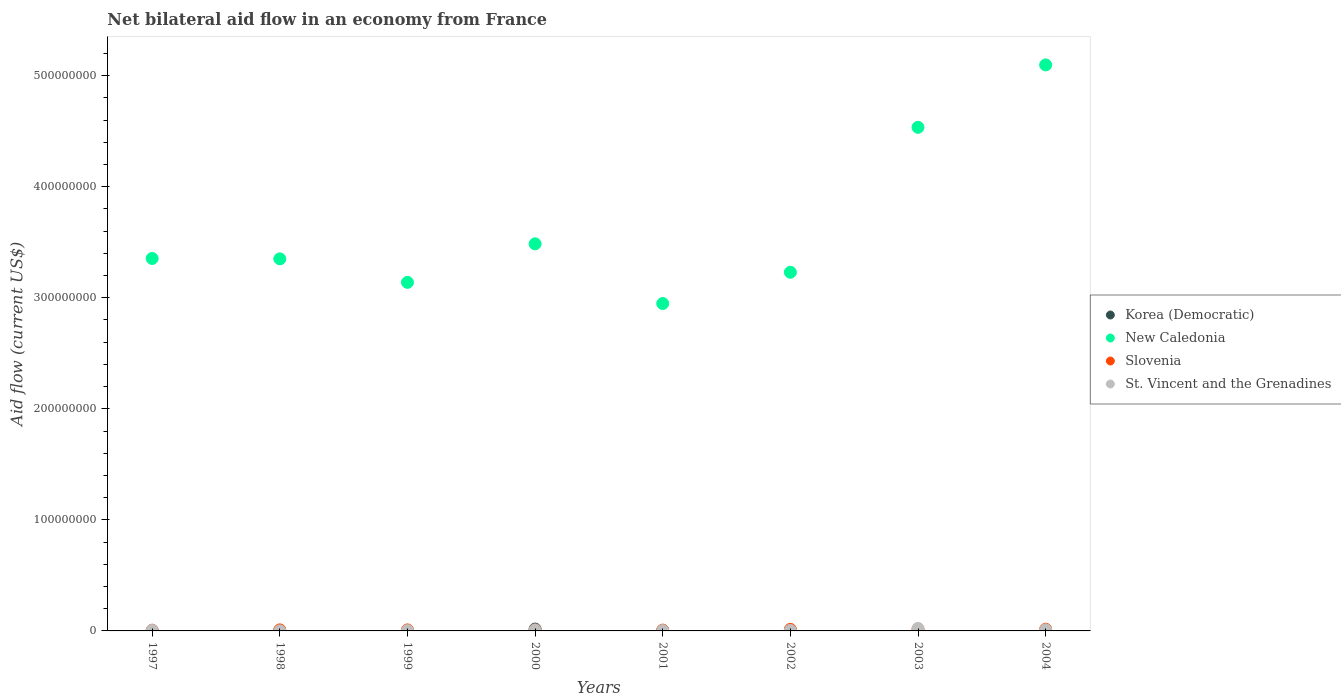What is the net bilateral aid flow in St. Vincent and the Grenadines in 2003?
Give a very brief answer. 2.23e+06. Across all years, what is the maximum net bilateral aid flow in Korea (Democratic)?
Your answer should be compact. 1.69e+06. In which year was the net bilateral aid flow in Korea (Democratic) maximum?
Keep it short and to the point. 2000. What is the total net bilateral aid flow in Slovenia in the graph?
Offer a terse response. 8.46e+06. What is the difference between the net bilateral aid flow in New Caledonia in 1999 and that in 2000?
Keep it short and to the point. -3.47e+07. What is the average net bilateral aid flow in New Caledonia per year?
Offer a very short reply. 3.64e+08. In the year 1998, what is the difference between the net bilateral aid flow in Korea (Democratic) and net bilateral aid flow in Slovenia?
Offer a very short reply. -8.50e+05. In how many years, is the net bilateral aid flow in Slovenia greater than 220000000 US$?
Give a very brief answer. 0. What is the ratio of the net bilateral aid flow in St. Vincent and the Grenadines in 2002 to that in 2004?
Your response must be concise. 0.48. Is the net bilateral aid flow in Slovenia in 2001 less than that in 2002?
Keep it short and to the point. Yes. What is the difference between the highest and the second highest net bilateral aid flow in St. Vincent and the Grenadines?
Your response must be concise. 1.20e+06. What is the difference between the highest and the lowest net bilateral aid flow in St. Vincent and the Grenadines?
Provide a short and direct response. 2.15e+06. Is the sum of the net bilateral aid flow in Slovenia in 1998 and 2003 greater than the maximum net bilateral aid flow in St. Vincent and the Grenadines across all years?
Offer a very short reply. Yes. Is it the case that in every year, the sum of the net bilateral aid flow in Slovenia and net bilateral aid flow in New Caledonia  is greater than the sum of net bilateral aid flow in Korea (Democratic) and net bilateral aid flow in St. Vincent and the Grenadines?
Offer a very short reply. Yes. Is the net bilateral aid flow in St. Vincent and the Grenadines strictly greater than the net bilateral aid flow in Korea (Democratic) over the years?
Provide a succinct answer. No. Is the net bilateral aid flow in New Caledonia strictly less than the net bilateral aid flow in Korea (Democratic) over the years?
Provide a succinct answer. No. How many years are there in the graph?
Provide a succinct answer. 8. What is the difference between two consecutive major ticks on the Y-axis?
Provide a short and direct response. 1.00e+08. Does the graph contain any zero values?
Provide a succinct answer. Yes. Where does the legend appear in the graph?
Make the answer very short. Center right. How many legend labels are there?
Provide a short and direct response. 4. How are the legend labels stacked?
Offer a terse response. Vertical. What is the title of the graph?
Offer a very short reply. Net bilateral aid flow in an economy from France. Does "Liberia" appear as one of the legend labels in the graph?
Give a very brief answer. No. What is the Aid flow (current US$) of Korea (Democratic) in 1997?
Give a very brief answer. 10000. What is the Aid flow (current US$) in New Caledonia in 1997?
Offer a very short reply. 3.35e+08. What is the Aid flow (current US$) of Slovenia in 1997?
Offer a very short reply. 6.60e+05. What is the Aid flow (current US$) of St. Vincent and the Grenadines in 1997?
Your response must be concise. 5.20e+05. What is the Aid flow (current US$) of Korea (Democratic) in 1998?
Your answer should be compact. 8.00e+04. What is the Aid flow (current US$) of New Caledonia in 1998?
Your response must be concise. 3.35e+08. What is the Aid flow (current US$) in Slovenia in 1998?
Give a very brief answer. 9.30e+05. What is the Aid flow (current US$) in New Caledonia in 1999?
Offer a terse response. 3.14e+08. What is the Aid flow (current US$) of Slovenia in 1999?
Keep it short and to the point. 9.00e+05. What is the Aid flow (current US$) in St. Vincent and the Grenadines in 1999?
Keep it short and to the point. 3.60e+05. What is the Aid flow (current US$) of Korea (Democratic) in 2000?
Your response must be concise. 1.69e+06. What is the Aid flow (current US$) of New Caledonia in 2000?
Give a very brief answer. 3.49e+08. What is the Aid flow (current US$) in Slovenia in 2000?
Make the answer very short. 8.50e+05. What is the Aid flow (current US$) in St. Vincent and the Grenadines in 2000?
Your answer should be compact. 8.70e+05. What is the Aid flow (current US$) in Korea (Democratic) in 2001?
Provide a short and direct response. 2.70e+05. What is the Aid flow (current US$) of New Caledonia in 2001?
Your answer should be compact. 2.95e+08. What is the Aid flow (current US$) in Slovenia in 2001?
Offer a terse response. 7.40e+05. What is the Aid flow (current US$) in New Caledonia in 2002?
Give a very brief answer. 3.23e+08. What is the Aid flow (current US$) of Slovenia in 2002?
Offer a terse response. 1.40e+06. What is the Aid flow (current US$) of St. Vincent and the Grenadines in 2002?
Keep it short and to the point. 4.90e+05. What is the Aid flow (current US$) in New Caledonia in 2003?
Keep it short and to the point. 4.53e+08. What is the Aid flow (current US$) in Slovenia in 2003?
Give a very brief answer. 1.44e+06. What is the Aid flow (current US$) in St. Vincent and the Grenadines in 2003?
Your response must be concise. 2.23e+06. What is the Aid flow (current US$) of New Caledonia in 2004?
Offer a terse response. 5.10e+08. What is the Aid flow (current US$) in Slovenia in 2004?
Make the answer very short. 1.54e+06. What is the Aid flow (current US$) in St. Vincent and the Grenadines in 2004?
Make the answer very short. 1.03e+06. Across all years, what is the maximum Aid flow (current US$) in Korea (Democratic)?
Provide a short and direct response. 1.69e+06. Across all years, what is the maximum Aid flow (current US$) in New Caledonia?
Your response must be concise. 5.10e+08. Across all years, what is the maximum Aid flow (current US$) in Slovenia?
Keep it short and to the point. 1.54e+06. Across all years, what is the maximum Aid flow (current US$) of St. Vincent and the Grenadines?
Your answer should be very brief. 2.23e+06. Across all years, what is the minimum Aid flow (current US$) in New Caledonia?
Ensure brevity in your answer.  2.95e+08. What is the total Aid flow (current US$) of Korea (Democratic) in the graph?
Your answer should be compact. 2.59e+06. What is the total Aid flow (current US$) in New Caledonia in the graph?
Provide a succinct answer. 2.91e+09. What is the total Aid flow (current US$) of Slovenia in the graph?
Give a very brief answer. 8.46e+06. What is the total Aid flow (current US$) of St. Vincent and the Grenadines in the graph?
Keep it short and to the point. 5.88e+06. What is the difference between the Aid flow (current US$) of Korea (Democratic) in 1997 and that in 1998?
Give a very brief answer. -7.00e+04. What is the difference between the Aid flow (current US$) of Korea (Democratic) in 1997 and that in 1999?
Your answer should be compact. -6.00e+04. What is the difference between the Aid flow (current US$) in New Caledonia in 1997 and that in 1999?
Keep it short and to the point. 2.15e+07. What is the difference between the Aid flow (current US$) of Korea (Democratic) in 1997 and that in 2000?
Ensure brevity in your answer.  -1.68e+06. What is the difference between the Aid flow (current US$) in New Caledonia in 1997 and that in 2000?
Provide a short and direct response. -1.32e+07. What is the difference between the Aid flow (current US$) of St. Vincent and the Grenadines in 1997 and that in 2000?
Keep it short and to the point. -3.50e+05. What is the difference between the Aid flow (current US$) in New Caledonia in 1997 and that in 2001?
Give a very brief answer. 4.06e+07. What is the difference between the Aid flow (current US$) in Korea (Democratic) in 1997 and that in 2002?
Offer a terse response. -4.60e+05. What is the difference between the Aid flow (current US$) of New Caledonia in 1997 and that in 2002?
Your response must be concise. 1.24e+07. What is the difference between the Aid flow (current US$) of Slovenia in 1997 and that in 2002?
Provide a short and direct response. -7.40e+05. What is the difference between the Aid flow (current US$) in New Caledonia in 1997 and that in 2003?
Ensure brevity in your answer.  -1.18e+08. What is the difference between the Aid flow (current US$) in Slovenia in 1997 and that in 2003?
Keep it short and to the point. -7.80e+05. What is the difference between the Aid flow (current US$) of St. Vincent and the Grenadines in 1997 and that in 2003?
Your response must be concise. -1.71e+06. What is the difference between the Aid flow (current US$) in New Caledonia in 1997 and that in 2004?
Keep it short and to the point. -1.74e+08. What is the difference between the Aid flow (current US$) of Slovenia in 1997 and that in 2004?
Provide a succinct answer. -8.80e+05. What is the difference between the Aid flow (current US$) in St. Vincent and the Grenadines in 1997 and that in 2004?
Make the answer very short. -5.10e+05. What is the difference between the Aid flow (current US$) of Korea (Democratic) in 1998 and that in 1999?
Offer a very short reply. 10000. What is the difference between the Aid flow (current US$) of New Caledonia in 1998 and that in 1999?
Offer a terse response. 2.12e+07. What is the difference between the Aid flow (current US$) of Slovenia in 1998 and that in 1999?
Provide a short and direct response. 3.00e+04. What is the difference between the Aid flow (current US$) in St. Vincent and the Grenadines in 1998 and that in 1999?
Your answer should be compact. -2.80e+05. What is the difference between the Aid flow (current US$) of Korea (Democratic) in 1998 and that in 2000?
Give a very brief answer. -1.61e+06. What is the difference between the Aid flow (current US$) of New Caledonia in 1998 and that in 2000?
Offer a very short reply. -1.35e+07. What is the difference between the Aid flow (current US$) of St. Vincent and the Grenadines in 1998 and that in 2000?
Your answer should be compact. -7.90e+05. What is the difference between the Aid flow (current US$) in New Caledonia in 1998 and that in 2001?
Your answer should be very brief. 4.02e+07. What is the difference between the Aid flow (current US$) in Slovenia in 1998 and that in 2001?
Provide a succinct answer. 1.90e+05. What is the difference between the Aid flow (current US$) of Korea (Democratic) in 1998 and that in 2002?
Make the answer very short. -3.90e+05. What is the difference between the Aid flow (current US$) in New Caledonia in 1998 and that in 2002?
Ensure brevity in your answer.  1.21e+07. What is the difference between the Aid flow (current US$) of Slovenia in 1998 and that in 2002?
Keep it short and to the point. -4.70e+05. What is the difference between the Aid flow (current US$) of St. Vincent and the Grenadines in 1998 and that in 2002?
Offer a terse response. -4.10e+05. What is the difference between the Aid flow (current US$) in New Caledonia in 1998 and that in 2003?
Offer a very short reply. -1.18e+08. What is the difference between the Aid flow (current US$) of Slovenia in 1998 and that in 2003?
Give a very brief answer. -5.10e+05. What is the difference between the Aid flow (current US$) in St. Vincent and the Grenadines in 1998 and that in 2003?
Provide a succinct answer. -2.15e+06. What is the difference between the Aid flow (current US$) in New Caledonia in 1998 and that in 2004?
Make the answer very short. -1.75e+08. What is the difference between the Aid flow (current US$) in Slovenia in 1998 and that in 2004?
Offer a terse response. -6.10e+05. What is the difference between the Aid flow (current US$) in St. Vincent and the Grenadines in 1998 and that in 2004?
Offer a terse response. -9.50e+05. What is the difference between the Aid flow (current US$) of Korea (Democratic) in 1999 and that in 2000?
Provide a succinct answer. -1.62e+06. What is the difference between the Aid flow (current US$) of New Caledonia in 1999 and that in 2000?
Keep it short and to the point. -3.47e+07. What is the difference between the Aid flow (current US$) in Slovenia in 1999 and that in 2000?
Make the answer very short. 5.00e+04. What is the difference between the Aid flow (current US$) in St. Vincent and the Grenadines in 1999 and that in 2000?
Give a very brief answer. -5.10e+05. What is the difference between the Aid flow (current US$) in Korea (Democratic) in 1999 and that in 2001?
Give a very brief answer. -2.00e+05. What is the difference between the Aid flow (current US$) of New Caledonia in 1999 and that in 2001?
Provide a short and direct response. 1.91e+07. What is the difference between the Aid flow (current US$) in Korea (Democratic) in 1999 and that in 2002?
Your answer should be very brief. -4.00e+05. What is the difference between the Aid flow (current US$) of New Caledonia in 1999 and that in 2002?
Offer a terse response. -9.07e+06. What is the difference between the Aid flow (current US$) in Slovenia in 1999 and that in 2002?
Give a very brief answer. -5.00e+05. What is the difference between the Aid flow (current US$) of St. Vincent and the Grenadines in 1999 and that in 2002?
Your response must be concise. -1.30e+05. What is the difference between the Aid flow (current US$) in New Caledonia in 1999 and that in 2003?
Your answer should be compact. -1.40e+08. What is the difference between the Aid flow (current US$) of Slovenia in 1999 and that in 2003?
Make the answer very short. -5.40e+05. What is the difference between the Aid flow (current US$) of St. Vincent and the Grenadines in 1999 and that in 2003?
Provide a succinct answer. -1.87e+06. What is the difference between the Aid flow (current US$) in New Caledonia in 1999 and that in 2004?
Ensure brevity in your answer.  -1.96e+08. What is the difference between the Aid flow (current US$) of Slovenia in 1999 and that in 2004?
Provide a short and direct response. -6.40e+05. What is the difference between the Aid flow (current US$) of St. Vincent and the Grenadines in 1999 and that in 2004?
Offer a terse response. -6.70e+05. What is the difference between the Aid flow (current US$) of Korea (Democratic) in 2000 and that in 2001?
Provide a succinct answer. 1.42e+06. What is the difference between the Aid flow (current US$) in New Caledonia in 2000 and that in 2001?
Provide a succinct answer. 5.37e+07. What is the difference between the Aid flow (current US$) of St. Vincent and the Grenadines in 2000 and that in 2001?
Offer a terse response. 5.70e+05. What is the difference between the Aid flow (current US$) in Korea (Democratic) in 2000 and that in 2002?
Provide a short and direct response. 1.22e+06. What is the difference between the Aid flow (current US$) in New Caledonia in 2000 and that in 2002?
Keep it short and to the point. 2.56e+07. What is the difference between the Aid flow (current US$) of Slovenia in 2000 and that in 2002?
Keep it short and to the point. -5.50e+05. What is the difference between the Aid flow (current US$) of St. Vincent and the Grenadines in 2000 and that in 2002?
Offer a terse response. 3.80e+05. What is the difference between the Aid flow (current US$) of New Caledonia in 2000 and that in 2003?
Make the answer very short. -1.05e+08. What is the difference between the Aid flow (current US$) of Slovenia in 2000 and that in 2003?
Your answer should be very brief. -5.90e+05. What is the difference between the Aid flow (current US$) of St. Vincent and the Grenadines in 2000 and that in 2003?
Ensure brevity in your answer.  -1.36e+06. What is the difference between the Aid flow (current US$) in New Caledonia in 2000 and that in 2004?
Your response must be concise. -1.61e+08. What is the difference between the Aid flow (current US$) of Slovenia in 2000 and that in 2004?
Your response must be concise. -6.90e+05. What is the difference between the Aid flow (current US$) in St. Vincent and the Grenadines in 2000 and that in 2004?
Ensure brevity in your answer.  -1.60e+05. What is the difference between the Aid flow (current US$) of Korea (Democratic) in 2001 and that in 2002?
Provide a succinct answer. -2.00e+05. What is the difference between the Aid flow (current US$) of New Caledonia in 2001 and that in 2002?
Keep it short and to the point. -2.81e+07. What is the difference between the Aid flow (current US$) in Slovenia in 2001 and that in 2002?
Offer a very short reply. -6.60e+05. What is the difference between the Aid flow (current US$) in New Caledonia in 2001 and that in 2003?
Provide a short and direct response. -1.59e+08. What is the difference between the Aid flow (current US$) in Slovenia in 2001 and that in 2003?
Your response must be concise. -7.00e+05. What is the difference between the Aid flow (current US$) of St. Vincent and the Grenadines in 2001 and that in 2003?
Make the answer very short. -1.93e+06. What is the difference between the Aid flow (current US$) in New Caledonia in 2001 and that in 2004?
Your response must be concise. -2.15e+08. What is the difference between the Aid flow (current US$) in Slovenia in 2001 and that in 2004?
Your response must be concise. -8.00e+05. What is the difference between the Aid flow (current US$) in St. Vincent and the Grenadines in 2001 and that in 2004?
Give a very brief answer. -7.30e+05. What is the difference between the Aid flow (current US$) of New Caledonia in 2002 and that in 2003?
Ensure brevity in your answer.  -1.31e+08. What is the difference between the Aid flow (current US$) in Slovenia in 2002 and that in 2003?
Your answer should be very brief. -4.00e+04. What is the difference between the Aid flow (current US$) of St. Vincent and the Grenadines in 2002 and that in 2003?
Offer a very short reply. -1.74e+06. What is the difference between the Aid flow (current US$) in New Caledonia in 2002 and that in 2004?
Your response must be concise. -1.87e+08. What is the difference between the Aid flow (current US$) in Slovenia in 2002 and that in 2004?
Ensure brevity in your answer.  -1.40e+05. What is the difference between the Aid flow (current US$) of St. Vincent and the Grenadines in 2002 and that in 2004?
Your response must be concise. -5.40e+05. What is the difference between the Aid flow (current US$) of New Caledonia in 2003 and that in 2004?
Make the answer very short. -5.62e+07. What is the difference between the Aid flow (current US$) of Slovenia in 2003 and that in 2004?
Provide a succinct answer. -1.00e+05. What is the difference between the Aid flow (current US$) in St. Vincent and the Grenadines in 2003 and that in 2004?
Your answer should be very brief. 1.20e+06. What is the difference between the Aid flow (current US$) in Korea (Democratic) in 1997 and the Aid flow (current US$) in New Caledonia in 1998?
Your answer should be compact. -3.35e+08. What is the difference between the Aid flow (current US$) of Korea (Democratic) in 1997 and the Aid flow (current US$) of Slovenia in 1998?
Provide a short and direct response. -9.20e+05. What is the difference between the Aid flow (current US$) in Korea (Democratic) in 1997 and the Aid flow (current US$) in St. Vincent and the Grenadines in 1998?
Offer a very short reply. -7.00e+04. What is the difference between the Aid flow (current US$) of New Caledonia in 1997 and the Aid flow (current US$) of Slovenia in 1998?
Keep it short and to the point. 3.34e+08. What is the difference between the Aid flow (current US$) in New Caledonia in 1997 and the Aid flow (current US$) in St. Vincent and the Grenadines in 1998?
Your answer should be compact. 3.35e+08. What is the difference between the Aid flow (current US$) of Slovenia in 1997 and the Aid flow (current US$) of St. Vincent and the Grenadines in 1998?
Provide a short and direct response. 5.80e+05. What is the difference between the Aid flow (current US$) in Korea (Democratic) in 1997 and the Aid flow (current US$) in New Caledonia in 1999?
Make the answer very short. -3.14e+08. What is the difference between the Aid flow (current US$) of Korea (Democratic) in 1997 and the Aid flow (current US$) of Slovenia in 1999?
Keep it short and to the point. -8.90e+05. What is the difference between the Aid flow (current US$) of Korea (Democratic) in 1997 and the Aid flow (current US$) of St. Vincent and the Grenadines in 1999?
Provide a succinct answer. -3.50e+05. What is the difference between the Aid flow (current US$) of New Caledonia in 1997 and the Aid flow (current US$) of Slovenia in 1999?
Provide a succinct answer. 3.34e+08. What is the difference between the Aid flow (current US$) in New Caledonia in 1997 and the Aid flow (current US$) in St. Vincent and the Grenadines in 1999?
Your answer should be very brief. 3.35e+08. What is the difference between the Aid flow (current US$) in Slovenia in 1997 and the Aid flow (current US$) in St. Vincent and the Grenadines in 1999?
Your answer should be very brief. 3.00e+05. What is the difference between the Aid flow (current US$) of Korea (Democratic) in 1997 and the Aid flow (current US$) of New Caledonia in 2000?
Your answer should be very brief. -3.49e+08. What is the difference between the Aid flow (current US$) in Korea (Democratic) in 1997 and the Aid flow (current US$) in Slovenia in 2000?
Ensure brevity in your answer.  -8.40e+05. What is the difference between the Aid flow (current US$) in Korea (Democratic) in 1997 and the Aid flow (current US$) in St. Vincent and the Grenadines in 2000?
Keep it short and to the point. -8.60e+05. What is the difference between the Aid flow (current US$) of New Caledonia in 1997 and the Aid flow (current US$) of Slovenia in 2000?
Provide a succinct answer. 3.35e+08. What is the difference between the Aid flow (current US$) in New Caledonia in 1997 and the Aid flow (current US$) in St. Vincent and the Grenadines in 2000?
Give a very brief answer. 3.35e+08. What is the difference between the Aid flow (current US$) of Slovenia in 1997 and the Aid flow (current US$) of St. Vincent and the Grenadines in 2000?
Your answer should be very brief. -2.10e+05. What is the difference between the Aid flow (current US$) in Korea (Democratic) in 1997 and the Aid flow (current US$) in New Caledonia in 2001?
Make the answer very short. -2.95e+08. What is the difference between the Aid flow (current US$) in Korea (Democratic) in 1997 and the Aid flow (current US$) in Slovenia in 2001?
Keep it short and to the point. -7.30e+05. What is the difference between the Aid flow (current US$) in Korea (Democratic) in 1997 and the Aid flow (current US$) in St. Vincent and the Grenadines in 2001?
Offer a very short reply. -2.90e+05. What is the difference between the Aid flow (current US$) in New Caledonia in 1997 and the Aid flow (current US$) in Slovenia in 2001?
Provide a short and direct response. 3.35e+08. What is the difference between the Aid flow (current US$) of New Caledonia in 1997 and the Aid flow (current US$) of St. Vincent and the Grenadines in 2001?
Keep it short and to the point. 3.35e+08. What is the difference between the Aid flow (current US$) of Korea (Democratic) in 1997 and the Aid flow (current US$) of New Caledonia in 2002?
Offer a terse response. -3.23e+08. What is the difference between the Aid flow (current US$) of Korea (Democratic) in 1997 and the Aid flow (current US$) of Slovenia in 2002?
Offer a terse response. -1.39e+06. What is the difference between the Aid flow (current US$) of Korea (Democratic) in 1997 and the Aid flow (current US$) of St. Vincent and the Grenadines in 2002?
Ensure brevity in your answer.  -4.80e+05. What is the difference between the Aid flow (current US$) in New Caledonia in 1997 and the Aid flow (current US$) in Slovenia in 2002?
Keep it short and to the point. 3.34e+08. What is the difference between the Aid flow (current US$) in New Caledonia in 1997 and the Aid flow (current US$) in St. Vincent and the Grenadines in 2002?
Keep it short and to the point. 3.35e+08. What is the difference between the Aid flow (current US$) in Slovenia in 1997 and the Aid flow (current US$) in St. Vincent and the Grenadines in 2002?
Your response must be concise. 1.70e+05. What is the difference between the Aid flow (current US$) in Korea (Democratic) in 1997 and the Aid flow (current US$) in New Caledonia in 2003?
Your response must be concise. -4.53e+08. What is the difference between the Aid flow (current US$) in Korea (Democratic) in 1997 and the Aid flow (current US$) in Slovenia in 2003?
Provide a succinct answer. -1.43e+06. What is the difference between the Aid flow (current US$) of Korea (Democratic) in 1997 and the Aid flow (current US$) of St. Vincent and the Grenadines in 2003?
Your response must be concise. -2.22e+06. What is the difference between the Aid flow (current US$) of New Caledonia in 1997 and the Aid flow (current US$) of Slovenia in 2003?
Your answer should be compact. 3.34e+08. What is the difference between the Aid flow (current US$) in New Caledonia in 1997 and the Aid flow (current US$) in St. Vincent and the Grenadines in 2003?
Your answer should be very brief. 3.33e+08. What is the difference between the Aid flow (current US$) of Slovenia in 1997 and the Aid flow (current US$) of St. Vincent and the Grenadines in 2003?
Provide a short and direct response. -1.57e+06. What is the difference between the Aid flow (current US$) in Korea (Democratic) in 1997 and the Aid flow (current US$) in New Caledonia in 2004?
Offer a very short reply. -5.10e+08. What is the difference between the Aid flow (current US$) of Korea (Democratic) in 1997 and the Aid flow (current US$) of Slovenia in 2004?
Offer a terse response. -1.53e+06. What is the difference between the Aid flow (current US$) in Korea (Democratic) in 1997 and the Aid flow (current US$) in St. Vincent and the Grenadines in 2004?
Ensure brevity in your answer.  -1.02e+06. What is the difference between the Aid flow (current US$) of New Caledonia in 1997 and the Aid flow (current US$) of Slovenia in 2004?
Provide a short and direct response. 3.34e+08. What is the difference between the Aid flow (current US$) of New Caledonia in 1997 and the Aid flow (current US$) of St. Vincent and the Grenadines in 2004?
Your answer should be very brief. 3.34e+08. What is the difference between the Aid flow (current US$) of Slovenia in 1997 and the Aid flow (current US$) of St. Vincent and the Grenadines in 2004?
Provide a succinct answer. -3.70e+05. What is the difference between the Aid flow (current US$) in Korea (Democratic) in 1998 and the Aid flow (current US$) in New Caledonia in 1999?
Offer a terse response. -3.14e+08. What is the difference between the Aid flow (current US$) of Korea (Democratic) in 1998 and the Aid flow (current US$) of Slovenia in 1999?
Provide a succinct answer. -8.20e+05. What is the difference between the Aid flow (current US$) in Korea (Democratic) in 1998 and the Aid flow (current US$) in St. Vincent and the Grenadines in 1999?
Keep it short and to the point. -2.80e+05. What is the difference between the Aid flow (current US$) of New Caledonia in 1998 and the Aid flow (current US$) of Slovenia in 1999?
Your answer should be very brief. 3.34e+08. What is the difference between the Aid flow (current US$) of New Caledonia in 1998 and the Aid flow (current US$) of St. Vincent and the Grenadines in 1999?
Your answer should be compact. 3.35e+08. What is the difference between the Aid flow (current US$) in Slovenia in 1998 and the Aid flow (current US$) in St. Vincent and the Grenadines in 1999?
Provide a succinct answer. 5.70e+05. What is the difference between the Aid flow (current US$) in Korea (Democratic) in 1998 and the Aid flow (current US$) in New Caledonia in 2000?
Your response must be concise. -3.48e+08. What is the difference between the Aid flow (current US$) of Korea (Democratic) in 1998 and the Aid flow (current US$) of Slovenia in 2000?
Your answer should be compact. -7.70e+05. What is the difference between the Aid flow (current US$) of Korea (Democratic) in 1998 and the Aid flow (current US$) of St. Vincent and the Grenadines in 2000?
Give a very brief answer. -7.90e+05. What is the difference between the Aid flow (current US$) in New Caledonia in 1998 and the Aid flow (current US$) in Slovenia in 2000?
Your answer should be compact. 3.34e+08. What is the difference between the Aid flow (current US$) of New Caledonia in 1998 and the Aid flow (current US$) of St. Vincent and the Grenadines in 2000?
Offer a very short reply. 3.34e+08. What is the difference between the Aid flow (current US$) in Korea (Democratic) in 1998 and the Aid flow (current US$) in New Caledonia in 2001?
Give a very brief answer. -2.95e+08. What is the difference between the Aid flow (current US$) of Korea (Democratic) in 1998 and the Aid flow (current US$) of Slovenia in 2001?
Keep it short and to the point. -6.60e+05. What is the difference between the Aid flow (current US$) in Korea (Democratic) in 1998 and the Aid flow (current US$) in St. Vincent and the Grenadines in 2001?
Keep it short and to the point. -2.20e+05. What is the difference between the Aid flow (current US$) in New Caledonia in 1998 and the Aid flow (current US$) in Slovenia in 2001?
Provide a short and direct response. 3.34e+08. What is the difference between the Aid flow (current US$) of New Caledonia in 1998 and the Aid flow (current US$) of St. Vincent and the Grenadines in 2001?
Provide a short and direct response. 3.35e+08. What is the difference between the Aid flow (current US$) of Slovenia in 1998 and the Aid flow (current US$) of St. Vincent and the Grenadines in 2001?
Provide a short and direct response. 6.30e+05. What is the difference between the Aid flow (current US$) of Korea (Democratic) in 1998 and the Aid flow (current US$) of New Caledonia in 2002?
Ensure brevity in your answer.  -3.23e+08. What is the difference between the Aid flow (current US$) in Korea (Democratic) in 1998 and the Aid flow (current US$) in Slovenia in 2002?
Your response must be concise. -1.32e+06. What is the difference between the Aid flow (current US$) of Korea (Democratic) in 1998 and the Aid flow (current US$) of St. Vincent and the Grenadines in 2002?
Your answer should be very brief. -4.10e+05. What is the difference between the Aid flow (current US$) of New Caledonia in 1998 and the Aid flow (current US$) of Slovenia in 2002?
Ensure brevity in your answer.  3.34e+08. What is the difference between the Aid flow (current US$) in New Caledonia in 1998 and the Aid flow (current US$) in St. Vincent and the Grenadines in 2002?
Your answer should be compact. 3.35e+08. What is the difference between the Aid flow (current US$) of Korea (Democratic) in 1998 and the Aid flow (current US$) of New Caledonia in 2003?
Offer a terse response. -4.53e+08. What is the difference between the Aid flow (current US$) of Korea (Democratic) in 1998 and the Aid flow (current US$) of Slovenia in 2003?
Offer a terse response. -1.36e+06. What is the difference between the Aid flow (current US$) in Korea (Democratic) in 1998 and the Aid flow (current US$) in St. Vincent and the Grenadines in 2003?
Provide a short and direct response. -2.15e+06. What is the difference between the Aid flow (current US$) in New Caledonia in 1998 and the Aid flow (current US$) in Slovenia in 2003?
Make the answer very short. 3.34e+08. What is the difference between the Aid flow (current US$) in New Caledonia in 1998 and the Aid flow (current US$) in St. Vincent and the Grenadines in 2003?
Your answer should be very brief. 3.33e+08. What is the difference between the Aid flow (current US$) of Slovenia in 1998 and the Aid flow (current US$) of St. Vincent and the Grenadines in 2003?
Offer a terse response. -1.30e+06. What is the difference between the Aid flow (current US$) of Korea (Democratic) in 1998 and the Aid flow (current US$) of New Caledonia in 2004?
Keep it short and to the point. -5.10e+08. What is the difference between the Aid flow (current US$) in Korea (Democratic) in 1998 and the Aid flow (current US$) in Slovenia in 2004?
Provide a succinct answer. -1.46e+06. What is the difference between the Aid flow (current US$) in Korea (Democratic) in 1998 and the Aid flow (current US$) in St. Vincent and the Grenadines in 2004?
Your answer should be very brief. -9.50e+05. What is the difference between the Aid flow (current US$) in New Caledonia in 1998 and the Aid flow (current US$) in Slovenia in 2004?
Your answer should be very brief. 3.33e+08. What is the difference between the Aid flow (current US$) of New Caledonia in 1998 and the Aid flow (current US$) of St. Vincent and the Grenadines in 2004?
Give a very brief answer. 3.34e+08. What is the difference between the Aid flow (current US$) of Slovenia in 1998 and the Aid flow (current US$) of St. Vincent and the Grenadines in 2004?
Give a very brief answer. -1.00e+05. What is the difference between the Aid flow (current US$) in Korea (Democratic) in 1999 and the Aid flow (current US$) in New Caledonia in 2000?
Your answer should be compact. -3.48e+08. What is the difference between the Aid flow (current US$) in Korea (Democratic) in 1999 and the Aid flow (current US$) in Slovenia in 2000?
Your answer should be very brief. -7.80e+05. What is the difference between the Aid flow (current US$) of Korea (Democratic) in 1999 and the Aid flow (current US$) of St. Vincent and the Grenadines in 2000?
Your answer should be very brief. -8.00e+05. What is the difference between the Aid flow (current US$) of New Caledonia in 1999 and the Aid flow (current US$) of Slovenia in 2000?
Provide a short and direct response. 3.13e+08. What is the difference between the Aid flow (current US$) in New Caledonia in 1999 and the Aid flow (current US$) in St. Vincent and the Grenadines in 2000?
Make the answer very short. 3.13e+08. What is the difference between the Aid flow (current US$) in Korea (Democratic) in 1999 and the Aid flow (current US$) in New Caledonia in 2001?
Provide a succinct answer. -2.95e+08. What is the difference between the Aid flow (current US$) of Korea (Democratic) in 1999 and the Aid flow (current US$) of Slovenia in 2001?
Your answer should be compact. -6.70e+05. What is the difference between the Aid flow (current US$) in Korea (Democratic) in 1999 and the Aid flow (current US$) in St. Vincent and the Grenadines in 2001?
Offer a very short reply. -2.30e+05. What is the difference between the Aid flow (current US$) in New Caledonia in 1999 and the Aid flow (current US$) in Slovenia in 2001?
Provide a succinct answer. 3.13e+08. What is the difference between the Aid flow (current US$) of New Caledonia in 1999 and the Aid flow (current US$) of St. Vincent and the Grenadines in 2001?
Offer a terse response. 3.14e+08. What is the difference between the Aid flow (current US$) of Slovenia in 1999 and the Aid flow (current US$) of St. Vincent and the Grenadines in 2001?
Your answer should be compact. 6.00e+05. What is the difference between the Aid flow (current US$) in Korea (Democratic) in 1999 and the Aid flow (current US$) in New Caledonia in 2002?
Your response must be concise. -3.23e+08. What is the difference between the Aid flow (current US$) in Korea (Democratic) in 1999 and the Aid flow (current US$) in Slovenia in 2002?
Provide a succinct answer. -1.33e+06. What is the difference between the Aid flow (current US$) in Korea (Democratic) in 1999 and the Aid flow (current US$) in St. Vincent and the Grenadines in 2002?
Offer a terse response. -4.20e+05. What is the difference between the Aid flow (current US$) in New Caledonia in 1999 and the Aid flow (current US$) in Slovenia in 2002?
Your response must be concise. 3.12e+08. What is the difference between the Aid flow (current US$) in New Caledonia in 1999 and the Aid flow (current US$) in St. Vincent and the Grenadines in 2002?
Offer a terse response. 3.13e+08. What is the difference between the Aid flow (current US$) in Korea (Democratic) in 1999 and the Aid flow (current US$) in New Caledonia in 2003?
Your response must be concise. -4.53e+08. What is the difference between the Aid flow (current US$) of Korea (Democratic) in 1999 and the Aid flow (current US$) of Slovenia in 2003?
Offer a very short reply. -1.37e+06. What is the difference between the Aid flow (current US$) of Korea (Democratic) in 1999 and the Aid flow (current US$) of St. Vincent and the Grenadines in 2003?
Offer a terse response. -2.16e+06. What is the difference between the Aid flow (current US$) in New Caledonia in 1999 and the Aid flow (current US$) in Slovenia in 2003?
Offer a terse response. 3.12e+08. What is the difference between the Aid flow (current US$) of New Caledonia in 1999 and the Aid flow (current US$) of St. Vincent and the Grenadines in 2003?
Ensure brevity in your answer.  3.12e+08. What is the difference between the Aid flow (current US$) of Slovenia in 1999 and the Aid flow (current US$) of St. Vincent and the Grenadines in 2003?
Your response must be concise. -1.33e+06. What is the difference between the Aid flow (current US$) of Korea (Democratic) in 1999 and the Aid flow (current US$) of New Caledonia in 2004?
Your answer should be very brief. -5.10e+08. What is the difference between the Aid flow (current US$) of Korea (Democratic) in 1999 and the Aid flow (current US$) of Slovenia in 2004?
Provide a succinct answer. -1.47e+06. What is the difference between the Aid flow (current US$) in Korea (Democratic) in 1999 and the Aid flow (current US$) in St. Vincent and the Grenadines in 2004?
Give a very brief answer. -9.60e+05. What is the difference between the Aid flow (current US$) of New Caledonia in 1999 and the Aid flow (current US$) of Slovenia in 2004?
Your answer should be compact. 3.12e+08. What is the difference between the Aid flow (current US$) of New Caledonia in 1999 and the Aid flow (current US$) of St. Vincent and the Grenadines in 2004?
Offer a terse response. 3.13e+08. What is the difference between the Aid flow (current US$) of Slovenia in 1999 and the Aid flow (current US$) of St. Vincent and the Grenadines in 2004?
Provide a short and direct response. -1.30e+05. What is the difference between the Aid flow (current US$) of Korea (Democratic) in 2000 and the Aid flow (current US$) of New Caledonia in 2001?
Offer a terse response. -2.93e+08. What is the difference between the Aid flow (current US$) of Korea (Democratic) in 2000 and the Aid flow (current US$) of Slovenia in 2001?
Provide a succinct answer. 9.50e+05. What is the difference between the Aid flow (current US$) of Korea (Democratic) in 2000 and the Aid flow (current US$) of St. Vincent and the Grenadines in 2001?
Give a very brief answer. 1.39e+06. What is the difference between the Aid flow (current US$) of New Caledonia in 2000 and the Aid flow (current US$) of Slovenia in 2001?
Provide a succinct answer. 3.48e+08. What is the difference between the Aid flow (current US$) in New Caledonia in 2000 and the Aid flow (current US$) in St. Vincent and the Grenadines in 2001?
Your response must be concise. 3.48e+08. What is the difference between the Aid flow (current US$) of Slovenia in 2000 and the Aid flow (current US$) of St. Vincent and the Grenadines in 2001?
Offer a very short reply. 5.50e+05. What is the difference between the Aid flow (current US$) of Korea (Democratic) in 2000 and the Aid flow (current US$) of New Caledonia in 2002?
Ensure brevity in your answer.  -3.21e+08. What is the difference between the Aid flow (current US$) in Korea (Democratic) in 2000 and the Aid flow (current US$) in St. Vincent and the Grenadines in 2002?
Your answer should be compact. 1.20e+06. What is the difference between the Aid flow (current US$) in New Caledonia in 2000 and the Aid flow (current US$) in Slovenia in 2002?
Your response must be concise. 3.47e+08. What is the difference between the Aid flow (current US$) of New Caledonia in 2000 and the Aid flow (current US$) of St. Vincent and the Grenadines in 2002?
Ensure brevity in your answer.  3.48e+08. What is the difference between the Aid flow (current US$) of Korea (Democratic) in 2000 and the Aid flow (current US$) of New Caledonia in 2003?
Offer a very short reply. -4.52e+08. What is the difference between the Aid flow (current US$) of Korea (Democratic) in 2000 and the Aid flow (current US$) of Slovenia in 2003?
Your answer should be compact. 2.50e+05. What is the difference between the Aid flow (current US$) of Korea (Democratic) in 2000 and the Aid flow (current US$) of St. Vincent and the Grenadines in 2003?
Your response must be concise. -5.40e+05. What is the difference between the Aid flow (current US$) of New Caledonia in 2000 and the Aid flow (current US$) of Slovenia in 2003?
Offer a terse response. 3.47e+08. What is the difference between the Aid flow (current US$) in New Caledonia in 2000 and the Aid flow (current US$) in St. Vincent and the Grenadines in 2003?
Provide a succinct answer. 3.46e+08. What is the difference between the Aid flow (current US$) in Slovenia in 2000 and the Aid flow (current US$) in St. Vincent and the Grenadines in 2003?
Make the answer very short. -1.38e+06. What is the difference between the Aid flow (current US$) in Korea (Democratic) in 2000 and the Aid flow (current US$) in New Caledonia in 2004?
Provide a succinct answer. -5.08e+08. What is the difference between the Aid flow (current US$) of Korea (Democratic) in 2000 and the Aid flow (current US$) of Slovenia in 2004?
Give a very brief answer. 1.50e+05. What is the difference between the Aid flow (current US$) in New Caledonia in 2000 and the Aid flow (current US$) in Slovenia in 2004?
Provide a short and direct response. 3.47e+08. What is the difference between the Aid flow (current US$) in New Caledonia in 2000 and the Aid flow (current US$) in St. Vincent and the Grenadines in 2004?
Keep it short and to the point. 3.48e+08. What is the difference between the Aid flow (current US$) of Korea (Democratic) in 2001 and the Aid flow (current US$) of New Caledonia in 2002?
Provide a succinct answer. -3.23e+08. What is the difference between the Aid flow (current US$) in Korea (Democratic) in 2001 and the Aid flow (current US$) in Slovenia in 2002?
Keep it short and to the point. -1.13e+06. What is the difference between the Aid flow (current US$) in Korea (Democratic) in 2001 and the Aid flow (current US$) in St. Vincent and the Grenadines in 2002?
Ensure brevity in your answer.  -2.20e+05. What is the difference between the Aid flow (current US$) in New Caledonia in 2001 and the Aid flow (current US$) in Slovenia in 2002?
Keep it short and to the point. 2.93e+08. What is the difference between the Aid flow (current US$) of New Caledonia in 2001 and the Aid flow (current US$) of St. Vincent and the Grenadines in 2002?
Keep it short and to the point. 2.94e+08. What is the difference between the Aid flow (current US$) of Korea (Democratic) in 2001 and the Aid flow (current US$) of New Caledonia in 2003?
Give a very brief answer. -4.53e+08. What is the difference between the Aid flow (current US$) of Korea (Democratic) in 2001 and the Aid flow (current US$) of Slovenia in 2003?
Make the answer very short. -1.17e+06. What is the difference between the Aid flow (current US$) in Korea (Democratic) in 2001 and the Aid flow (current US$) in St. Vincent and the Grenadines in 2003?
Offer a terse response. -1.96e+06. What is the difference between the Aid flow (current US$) in New Caledonia in 2001 and the Aid flow (current US$) in Slovenia in 2003?
Give a very brief answer. 2.93e+08. What is the difference between the Aid flow (current US$) in New Caledonia in 2001 and the Aid flow (current US$) in St. Vincent and the Grenadines in 2003?
Offer a very short reply. 2.93e+08. What is the difference between the Aid flow (current US$) in Slovenia in 2001 and the Aid flow (current US$) in St. Vincent and the Grenadines in 2003?
Ensure brevity in your answer.  -1.49e+06. What is the difference between the Aid flow (current US$) in Korea (Democratic) in 2001 and the Aid flow (current US$) in New Caledonia in 2004?
Provide a short and direct response. -5.09e+08. What is the difference between the Aid flow (current US$) of Korea (Democratic) in 2001 and the Aid flow (current US$) of Slovenia in 2004?
Keep it short and to the point. -1.27e+06. What is the difference between the Aid flow (current US$) of Korea (Democratic) in 2001 and the Aid flow (current US$) of St. Vincent and the Grenadines in 2004?
Provide a short and direct response. -7.60e+05. What is the difference between the Aid flow (current US$) in New Caledonia in 2001 and the Aid flow (current US$) in Slovenia in 2004?
Ensure brevity in your answer.  2.93e+08. What is the difference between the Aid flow (current US$) in New Caledonia in 2001 and the Aid flow (current US$) in St. Vincent and the Grenadines in 2004?
Ensure brevity in your answer.  2.94e+08. What is the difference between the Aid flow (current US$) of Slovenia in 2001 and the Aid flow (current US$) of St. Vincent and the Grenadines in 2004?
Provide a short and direct response. -2.90e+05. What is the difference between the Aid flow (current US$) in Korea (Democratic) in 2002 and the Aid flow (current US$) in New Caledonia in 2003?
Provide a succinct answer. -4.53e+08. What is the difference between the Aid flow (current US$) of Korea (Democratic) in 2002 and the Aid flow (current US$) of Slovenia in 2003?
Your answer should be very brief. -9.70e+05. What is the difference between the Aid flow (current US$) in Korea (Democratic) in 2002 and the Aid flow (current US$) in St. Vincent and the Grenadines in 2003?
Provide a succinct answer. -1.76e+06. What is the difference between the Aid flow (current US$) of New Caledonia in 2002 and the Aid flow (current US$) of Slovenia in 2003?
Provide a succinct answer. 3.22e+08. What is the difference between the Aid flow (current US$) in New Caledonia in 2002 and the Aid flow (current US$) in St. Vincent and the Grenadines in 2003?
Make the answer very short. 3.21e+08. What is the difference between the Aid flow (current US$) in Slovenia in 2002 and the Aid flow (current US$) in St. Vincent and the Grenadines in 2003?
Your answer should be compact. -8.30e+05. What is the difference between the Aid flow (current US$) in Korea (Democratic) in 2002 and the Aid flow (current US$) in New Caledonia in 2004?
Provide a short and direct response. -5.09e+08. What is the difference between the Aid flow (current US$) of Korea (Democratic) in 2002 and the Aid flow (current US$) of Slovenia in 2004?
Your answer should be very brief. -1.07e+06. What is the difference between the Aid flow (current US$) in Korea (Democratic) in 2002 and the Aid flow (current US$) in St. Vincent and the Grenadines in 2004?
Your response must be concise. -5.60e+05. What is the difference between the Aid flow (current US$) in New Caledonia in 2002 and the Aid flow (current US$) in Slovenia in 2004?
Your response must be concise. 3.21e+08. What is the difference between the Aid flow (current US$) of New Caledonia in 2002 and the Aid flow (current US$) of St. Vincent and the Grenadines in 2004?
Ensure brevity in your answer.  3.22e+08. What is the difference between the Aid flow (current US$) of Slovenia in 2002 and the Aid flow (current US$) of St. Vincent and the Grenadines in 2004?
Your answer should be compact. 3.70e+05. What is the difference between the Aid flow (current US$) of New Caledonia in 2003 and the Aid flow (current US$) of Slovenia in 2004?
Your response must be concise. 4.52e+08. What is the difference between the Aid flow (current US$) of New Caledonia in 2003 and the Aid flow (current US$) of St. Vincent and the Grenadines in 2004?
Provide a succinct answer. 4.52e+08. What is the average Aid flow (current US$) of Korea (Democratic) per year?
Make the answer very short. 3.24e+05. What is the average Aid flow (current US$) in New Caledonia per year?
Ensure brevity in your answer.  3.64e+08. What is the average Aid flow (current US$) of Slovenia per year?
Your answer should be very brief. 1.06e+06. What is the average Aid flow (current US$) of St. Vincent and the Grenadines per year?
Keep it short and to the point. 7.35e+05. In the year 1997, what is the difference between the Aid flow (current US$) of Korea (Democratic) and Aid flow (current US$) of New Caledonia?
Your answer should be very brief. -3.35e+08. In the year 1997, what is the difference between the Aid flow (current US$) in Korea (Democratic) and Aid flow (current US$) in Slovenia?
Keep it short and to the point. -6.50e+05. In the year 1997, what is the difference between the Aid flow (current US$) of Korea (Democratic) and Aid flow (current US$) of St. Vincent and the Grenadines?
Provide a short and direct response. -5.10e+05. In the year 1997, what is the difference between the Aid flow (current US$) in New Caledonia and Aid flow (current US$) in Slovenia?
Your response must be concise. 3.35e+08. In the year 1997, what is the difference between the Aid flow (current US$) in New Caledonia and Aid flow (current US$) in St. Vincent and the Grenadines?
Your answer should be very brief. 3.35e+08. In the year 1998, what is the difference between the Aid flow (current US$) of Korea (Democratic) and Aid flow (current US$) of New Caledonia?
Provide a short and direct response. -3.35e+08. In the year 1998, what is the difference between the Aid flow (current US$) of Korea (Democratic) and Aid flow (current US$) of Slovenia?
Your response must be concise. -8.50e+05. In the year 1998, what is the difference between the Aid flow (current US$) in New Caledonia and Aid flow (current US$) in Slovenia?
Make the answer very short. 3.34e+08. In the year 1998, what is the difference between the Aid flow (current US$) of New Caledonia and Aid flow (current US$) of St. Vincent and the Grenadines?
Provide a succinct answer. 3.35e+08. In the year 1998, what is the difference between the Aid flow (current US$) in Slovenia and Aid flow (current US$) in St. Vincent and the Grenadines?
Your answer should be compact. 8.50e+05. In the year 1999, what is the difference between the Aid flow (current US$) of Korea (Democratic) and Aid flow (current US$) of New Caledonia?
Offer a very short reply. -3.14e+08. In the year 1999, what is the difference between the Aid flow (current US$) of Korea (Democratic) and Aid flow (current US$) of Slovenia?
Your response must be concise. -8.30e+05. In the year 1999, what is the difference between the Aid flow (current US$) of Korea (Democratic) and Aid flow (current US$) of St. Vincent and the Grenadines?
Provide a short and direct response. -2.90e+05. In the year 1999, what is the difference between the Aid flow (current US$) of New Caledonia and Aid flow (current US$) of Slovenia?
Give a very brief answer. 3.13e+08. In the year 1999, what is the difference between the Aid flow (current US$) of New Caledonia and Aid flow (current US$) of St. Vincent and the Grenadines?
Provide a short and direct response. 3.14e+08. In the year 1999, what is the difference between the Aid flow (current US$) of Slovenia and Aid flow (current US$) of St. Vincent and the Grenadines?
Your answer should be very brief. 5.40e+05. In the year 2000, what is the difference between the Aid flow (current US$) of Korea (Democratic) and Aid flow (current US$) of New Caledonia?
Give a very brief answer. -3.47e+08. In the year 2000, what is the difference between the Aid flow (current US$) of Korea (Democratic) and Aid flow (current US$) of Slovenia?
Offer a very short reply. 8.40e+05. In the year 2000, what is the difference between the Aid flow (current US$) of Korea (Democratic) and Aid flow (current US$) of St. Vincent and the Grenadines?
Make the answer very short. 8.20e+05. In the year 2000, what is the difference between the Aid flow (current US$) in New Caledonia and Aid flow (current US$) in Slovenia?
Offer a terse response. 3.48e+08. In the year 2000, what is the difference between the Aid flow (current US$) in New Caledonia and Aid flow (current US$) in St. Vincent and the Grenadines?
Offer a terse response. 3.48e+08. In the year 2000, what is the difference between the Aid flow (current US$) of Slovenia and Aid flow (current US$) of St. Vincent and the Grenadines?
Provide a succinct answer. -2.00e+04. In the year 2001, what is the difference between the Aid flow (current US$) in Korea (Democratic) and Aid flow (current US$) in New Caledonia?
Your answer should be very brief. -2.95e+08. In the year 2001, what is the difference between the Aid flow (current US$) of Korea (Democratic) and Aid flow (current US$) of Slovenia?
Offer a terse response. -4.70e+05. In the year 2001, what is the difference between the Aid flow (current US$) of New Caledonia and Aid flow (current US$) of Slovenia?
Your response must be concise. 2.94e+08. In the year 2001, what is the difference between the Aid flow (current US$) in New Caledonia and Aid flow (current US$) in St. Vincent and the Grenadines?
Keep it short and to the point. 2.94e+08. In the year 2001, what is the difference between the Aid flow (current US$) of Slovenia and Aid flow (current US$) of St. Vincent and the Grenadines?
Your answer should be very brief. 4.40e+05. In the year 2002, what is the difference between the Aid flow (current US$) in Korea (Democratic) and Aid flow (current US$) in New Caledonia?
Make the answer very short. -3.22e+08. In the year 2002, what is the difference between the Aid flow (current US$) in Korea (Democratic) and Aid flow (current US$) in Slovenia?
Your answer should be very brief. -9.30e+05. In the year 2002, what is the difference between the Aid flow (current US$) of Korea (Democratic) and Aid flow (current US$) of St. Vincent and the Grenadines?
Make the answer very short. -2.00e+04. In the year 2002, what is the difference between the Aid flow (current US$) in New Caledonia and Aid flow (current US$) in Slovenia?
Keep it short and to the point. 3.22e+08. In the year 2002, what is the difference between the Aid flow (current US$) of New Caledonia and Aid flow (current US$) of St. Vincent and the Grenadines?
Your answer should be very brief. 3.22e+08. In the year 2002, what is the difference between the Aid flow (current US$) in Slovenia and Aid flow (current US$) in St. Vincent and the Grenadines?
Make the answer very short. 9.10e+05. In the year 2003, what is the difference between the Aid flow (current US$) of New Caledonia and Aid flow (current US$) of Slovenia?
Offer a terse response. 4.52e+08. In the year 2003, what is the difference between the Aid flow (current US$) of New Caledonia and Aid flow (current US$) of St. Vincent and the Grenadines?
Offer a terse response. 4.51e+08. In the year 2003, what is the difference between the Aid flow (current US$) of Slovenia and Aid flow (current US$) of St. Vincent and the Grenadines?
Give a very brief answer. -7.90e+05. In the year 2004, what is the difference between the Aid flow (current US$) of New Caledonia and Aid flow (current US$) of Slovenia?
Provide a short and direct response. 5.08e+08. In the year 2004, what is the difference between the Aid flow (current US$) in New Caledonia and Aid flow (current US$) in St. Vincent and the Grenadines?
Keep it short and to the point. 5.09e+08. In the year 2004, what is the difference between the Aid flow (current US$) of Slovenia and Aid flow (current US$) of St. Vincent and the Grenadines?
Your answer should be very brief. 5.10e+05. What is the ratio of the Aid flow (current US$) in Korea (Democratic) in 1997 to that in 1998?
Your response must be concise. 0.12. What is the ratio of the Aid flow (current US$) of Slovenia in 1997 to that in 1998?
Provide a succinct answer. 0.71. What is the ratio of the Aid flow (current US$) of Korea (Democratic) in 1997 to that in 1999?
Your answer should be very brief. 0.14. What is the ratio of the Aid flow (current US$) of New Caledonia in 1997 to that in 1999?
Offer a very short reply. 1.07. What is the ratio of the Aid flow (current US$) of Slovenia in 1997 to that in 1999?
Make the answer very short. 0.73. What is the ratio of the Aid flow (current US$) of St. Vincent and the Grenadines in 1997 to that in 1999?
Your answer should be very brief. 1.44. What is the ratio of the Aid flow (current US$) of Korea (Democratic) in 1997 to that in 2000?
Provide a succinct answer. 0.01. What is the ratio of the Aid flow (current US$) in New Caledonia in 1997 to that in 2000?
Provide a succinct answer. 0.96. What is the ratio of the Aid flow (current US$) in Slovenia in 1997 to that in 2000?
Provide a succinct answer. 0.78. What is the ratio of the Aid flow (current US$) of St. Vincent and the Grenadines in 1997 to that in 2000?
Your response must be concise. 0.6. What is the ratio of the Aid flow (current US$) of Korea (Democratic) in 1997 to that in 2001?
Your response must be concise. 0.04. What is the ratio of the Aid flow (current US$) in New Caledonia in 1997 to that in 2001?
Give a very brief answer. 1.14. What is the ratio of the Aid flow (current US$) in Slovenia in 1997 to that in 2001?
Make the answer very short. 0.89. What is the ratio of the Aid flow (current US$) of St. Vincent and the Grenadines in 1997 to that in 2001?
Provide a succinct answer. 1.73. What is the ratio of the Aid flow (current US$) of Korea (Democratic) in 1997 to that in 2002?
Offer a terse response. 0.02. What is the ratio of the Aid flow (current US$) of Slovenia in 1997 to that in 2002?
Keep it short and to the point. 0.47. What is the ratio of the Aid flow (current US$) of St. Vincent and the Grenadines in 1997 to that in 2002?
Your answer should be compact. 1.06. What is the ratio of the Aid flow (current US$) in New Caledonia in 1997 to that in 2003?
Ensure brevity in your answer.  0.74. What is the ratio of the Aid flow (current US$) of Slovenia in 1997 to that in 2003?
Offer a terse response. 0.46. What is the ratio of the Aid flow (current US$) of St. Vincent and the Grenadines in 1997 to that in 2003?
Provide a succinct answer. 0.23. What is the ratio of the Aid flow (current US$) in New Caledonia in 1997 to that in 2004?
Keep it short and to the point. 0.66. What is the ratio of the Aid flow (current US$) in Slovenia in 1997 to that in 2004?
Offer a terse response. 0.43. What is the ratio of the Aid flow (current US$) in St. Vincent and the Grenadines in 1997 to that in 2004?
Your answer should be very brief. 0.5. What is the ratio of the Aid flow (current US$) of New Caledonia in 1998 to that in 1999?
Keep it short and to the point. 1.07. What is the ratio of the Aid flow (current US$) in St. Vincent and the Grenadines in 1998 to that in 1999?
Offer a terse response. 0.22. What is the ratio of the Aid flow (current US$) of Korea (Democratic) in 1998 to that in 2000?
Offer a terse response. 0.05. What is the ratio of the Aid flow (current US$) of New Caledonia in 1998 to that in 2000?
Ensure brevity in your answer.  0.96. What is the ratio of the Aid flow (current US$) of Slovenia in 1998 to that in 2000?
Your answer should be compact. 1.09. What is the ratio of the Aid flow (current US$) in St. Vincent and the Grenadines in 1998 to that in 2000?
Provide a short and direct response. 0.09. What is the ratio of the Aid flow (current US$) of Korea (Democratic) in 1998 to that in 2001?
Provide a succinct answer. 0.3. What is the ratio of the Aid flow (current US$) in New Caledonia in 1998 to that in 2001?
Ensure brevity in your answer.  1.14. What is the ratio of the Aid flow (current US$) in Slovenia in 1998 to that in 2001?
Your answer should be compact. 1.26. What is the ratio of the Aid flow (current US$) in St. Vincent and the Grenadines in 1998 to that in 2001?
Give a very brief answer. 0.27. What is the ratio of the Aid flow (current US$) of Korea (Democratic) in 1998 to that in 2002?
Keep it short and to the point. 0.17. What is the ratio of the Aid flow (current US$) in New Caledonia in 1998 to that in 2002?
Give a very brief answer. 1.04. What is the ratio of the Aid flow (current US$) of Slovenia in 1998 to that in 2002?
Ensure brevity in your answer.  0.66. What is the ratio of the Aid flow (current US$) of St. Vincent and the Grenadines in 1998 to that in 2002?
Your response must be concise. 0.16. What is the ratio of the Aid flow (current US$) in New Caledonia in 1998 to that in 2003?
Your answer should be compact. 0.74. What is the ratio of the Aid flow (current US$) of Slovenia in 1998 to that in 2003?
Keep it short and to the point. 0.65. What is the ratio of the Aid flow (current US$) in St. Vincent and the Grenadines in 1998 to that in 2003?
Offer a terse response. 0.04. What is the ratio of the Aid flow (current US$) of New Caledonia in 1998 to that in 2004?
Give a very brief answer. 0.66. What is the ratio of the Aid flow (current US$) in Slovenia in 1998 to that in 2004?
Keep it short and to the point. 0.6. What is the ratio of the Aid flow (current US$) in St. Vincent and the Grenadines in 1998 to that in 2004?
Offer a very short reply. 0.08. What is the ratio of the Aid flow (current US$) of Korea (Democratic) in 1999 to that in 2000?
Give a very brief answer. 0.04. What is the ratio of the Aid flow (current US$) in New Caledonia in 1999 to that in 2000?
Your response must be concise. 0.9. What is the ratio of the Aid flow (current US$) in Slovenia in 1999 to that in 2000?
Give a very brief answer. 1.06. What is the ratio of the Aid flow (current US$) in St. Vincent and the Grenadines in 1999 to that in 2000?
Ensure brevity in your answer.  0.41. What is the ratio of the Aid flow (current US$) of Korea (Democratic) in 1999 to that in 2001?
Provide a succinct answer. 0.26. What is the ratio of the Aid flow (current US$) of New Caledonia in 1999 to that in 2001?
Ensure brevity in your answer.  1.06. What is the ratio of the Aid flow (current US$) in Slovenia in 1999 to that in 2001?
Your response must be concise. 1.22. What is the ratio of the Aid flow (current US$) of Korea (Democratic) in 1999 to that in 2002?
Offer a very short reply. 0.15. What is the ratio of the Aid flow (current US$) of New Caledonia in 1999 to that in 2002?
Provide a succinct answer. 0.97. What is the ratio of the Aid flow (current US$) in Slovenia in 1999 to that in 2002?
Your response must be concise. 0.64. What is the ratio of the Aid flow (current US$) of St. Vincent and the Grenadines in 1999 to that in 2002?
Ensure brevity in your answer.  0.73. What is the ratio of the Aid flow (current US$) of New Caledonia in 1999 to that in 2003?
Your response must be concise. 0.69. What is the ratio of the Aid flow (current US$) of Slovenia in 1999 to that in 2003?
Your answer should be very brief. 0.62. What is the ratio of the Aid flow (current US$) in St. Vincent and the Grenadines in 1999 to that in 2003?
Offer a very short reply. 0.16. What is the ratio of the Aid flow (current US$) of New Caledonia in 1999 to that in 2004?
Your answer should be very brief. 0.62. What is the ratio of the Aid flow (current US$) of Slovenia in 1999 to that in 2004?
Provide a short and direct response. 0.58. What is the ratio of the Aid flow (current US$) in St. Vincent and the Grenadines in 1999 to that in 2004?
Provide a short and direct response. 0.35. What is the ratio of the Aid flow (current US$) of Korea (Democratic) in 2000 to that in 2001?
Make the answer very short. 6.26. What is the ratio of the Aid flow (current US$) in New Caledonia in 2000 to that in 2001?
Keep it short and to the point. 1.18. What is the ratio of the Aid flow (current US$) of Slovenia in 2000 to that in 2001?
Offer a terse response. 1.15. What is the ratio of the Aid flow (current US$) in Korea (Democratic) in 2000 to that in 2002?
Keep it short and to the point. 3.6. What is the ratio of the Aid flow (current US$) of New Caledonia in 2000 to that in 2002?
Your answer should be compact. 1.08. What is the ratio of the Aid flow (current US$) in Slovenia in 2000 to that in 2002?
Make the answer very short. 0.61. What is the ratio of the Aid flow (current US$) in St. Vincent and the Grenadines in 2000 to that in 2002?
Make the answer very short. 1.78. What is the ratio of the Aid flow (current US$) in New Caledonia in 2000 to that in 2003?
Your answer should be very brief. 0.77. What is the ratio of the Aid flow (current US$) of Slovenia in 2000 to that in 2003?
Your answer should be very brief. 0.59. What is the ratio of the Aid flow (current US$) in St. Vincent and the Grenadines in 2000 to that in 2003?
Give a very brief answer. 0.39. What is the ratio of the Aid flow (current US$) in New Caledonia in 2000 to that in 2004?
Give a very brief answer. 0.68. What is the ratio of the Aid flow (current US$) of Slovenia in 2000 to that in 2004?
Your answer should be compact. 0.55. What is the ratio of the Aid flow (current US$) of St. Vincent and the Grenadines in 2000 to that in 2004?
Your answer should be very brief. 0.84. What is the ratio of the Aid flow (current US$) of Korea (Democratic) in 2001 to that in 2002?
Your answer should be very brief. 0.57. What is the ratio of the Aid flow (current US$) of New Caledonia in 2001 to that in 2002?
Your response must be concise. 0.91. What is the ratio of the Aid flow (current US$) of Slovenia in 2001 to that in 2002?
Your answer should be very brief. 0.53. What is the ratio of the Aid flow (current US$) of St. Vincent and the Grenadines in 2001 to that in 2002?
Offer a very short reply. 0.61. What is the ratio of the Aid flow (current US$) in New Caledonia in 2001 to that in 2003?
Give a very brief answer. 0.65. What is the ratio of the Aid flow (current US$) in Slovenia in 2001 to that in 2003?
Your answer should be compact. 0.51. What is the ratio of the Aid flow (current US$) of St. Vincent and the Grenadines in 2001 to that in 2003?
Your response must be concise. 0.13. What is the ratio of the Aid flow (current US$) of New Caledonia in 2001 to that in 2004?
Make the answer very short. 0.58. What is the ratio of the Aid flow (current US$) of Slovenia in 2001 to that in 2004?
Offer a very short reply. 0.48. What is the ratio of the Aid flow (current US$) in St. Vincent and the Grenadines in 2001 to that in 2004?
Your answer should be compact. 0.29. What is the ratio of the Aid flow (current US$) in New Caledonia in 2002 to that in 2003?
Your response must be concise. 0.71. What is the ratio of the Aid flow (current US$) of Slovenia in 2002 to that in 2003?
Provide a short and direct response. 0.97. What is the ratio of the Aid flow (current US$) in St. Vincent and the Grenadines in 2002 to that in 2003?
Your response must be concise. 0.22. What is the ratio of the Aid flow (current US$) in New Caledonia in 2002 to that in 2004?
Provide a succinct answer. 0.63. What is the ratio of the Aid flow (current US$) in St. Vincent and the Grenadines in 2002 to that in 2004?
Offer a very short reply. 0.48. What is the ratio of the Aid flow (current US$) in New Caledonia in 2003 to that in 2004?
Provide a succinct answer. 0.89. What is the ratio of the Aid flow (current US$) of Slovenia in 2003 to that in 2004?
Give a very brief answer. 0.94. What is the ratio of the Aid flow (current US$) in St. Vincent and the Grenadines in 2003 to that in 2004?
Provide a short and direct response. 2.17. What is the difference between the highest and the second highest Aid flow (current US$) of Korea (Democratic)?
Ensure brevity in your answer.  1.22e+06. What is the difference between the highest and the second highest Aid flow (current US$) in New Caledonia?
Provide a short and direct response. 5.62e+07. What is the difference between the highest and the second highest Aid flow (current US$) in Slovenia?
Your answer should be compact. 1.00e+05. What is the difference between the highest and the second highest Aid flow (current US$) in St. Vincent and the Grenadines?
Ensure brevity in your answer.  1.20e+06. What is the difference between the highest and the lowest Aid flow (current US$) in Korea (Democratic)?
Keep it short and to the point. 1.69e+06. What is the difference between the highest and the lowest Aid flow (current US$) of New Caledonia?
Give a very brief answer. 2.15e+08. What is the difference between the highest and the lowest Aid flow (current US$) of Slovenia?
Give a very brief answer. 8.80e+05. What is the difference between the highest and the lowest Aid flow (current US$) in St. Vincent and the Grenadines?
Your response must be concise. 2.15e+06. 